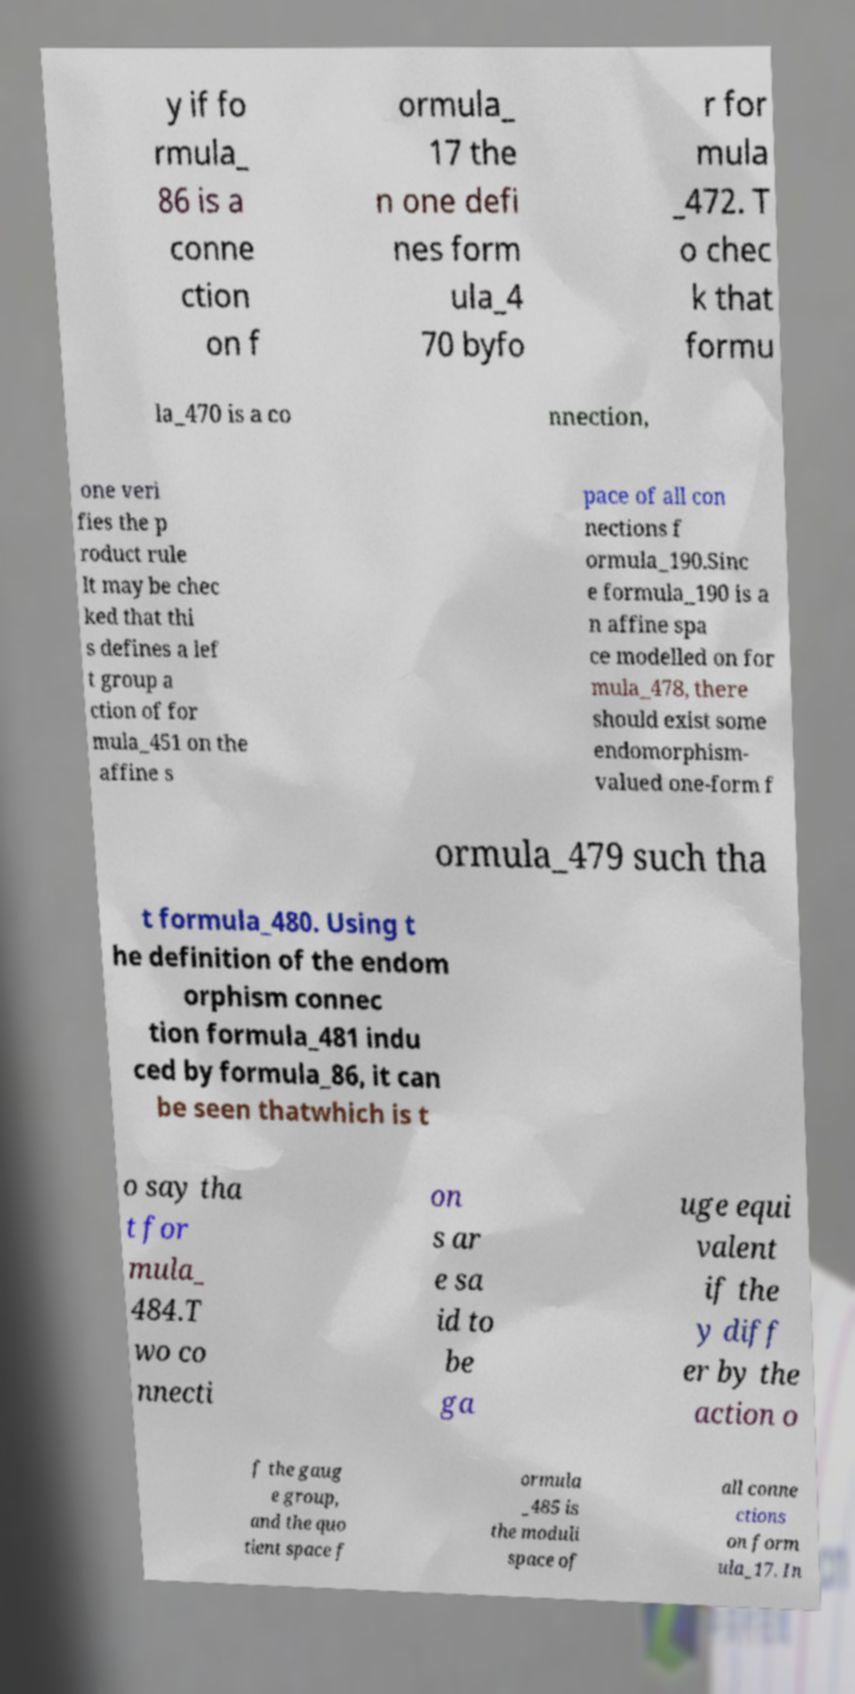I need the written content from this picture converted into text. Can you do that? y if fo rmula_ 86 is a conne ction on f ormula_ 17 the n one defi nes form ula_4 70 byfo r for mula _472. T o chec k that formu la_470 is a co nnection, one veri fies the p roduct rule It may be chec ked that thi s defines a lef t group a ction of for mula_451 on the affine s pace of all con nections f ormula_190.Sinc e formula_190 is a n affine spa ce modelled on for mula_478, there should exist some endomorphism- valued one-form f ormula_479 such tha t formula_480. Using t he definition of the endom orphism connec tion formula_481 indu ced by formula_86, it can be seen thatwhich is t o say tha t for mula_ 484.T wo co nnecti on s ar e sa id to be ga uge equi valent if the y diff er by the action o f the gaug e group, and the quo tient space f ormula _485 is the moduli space of all conne ctions on form ula_17. In 